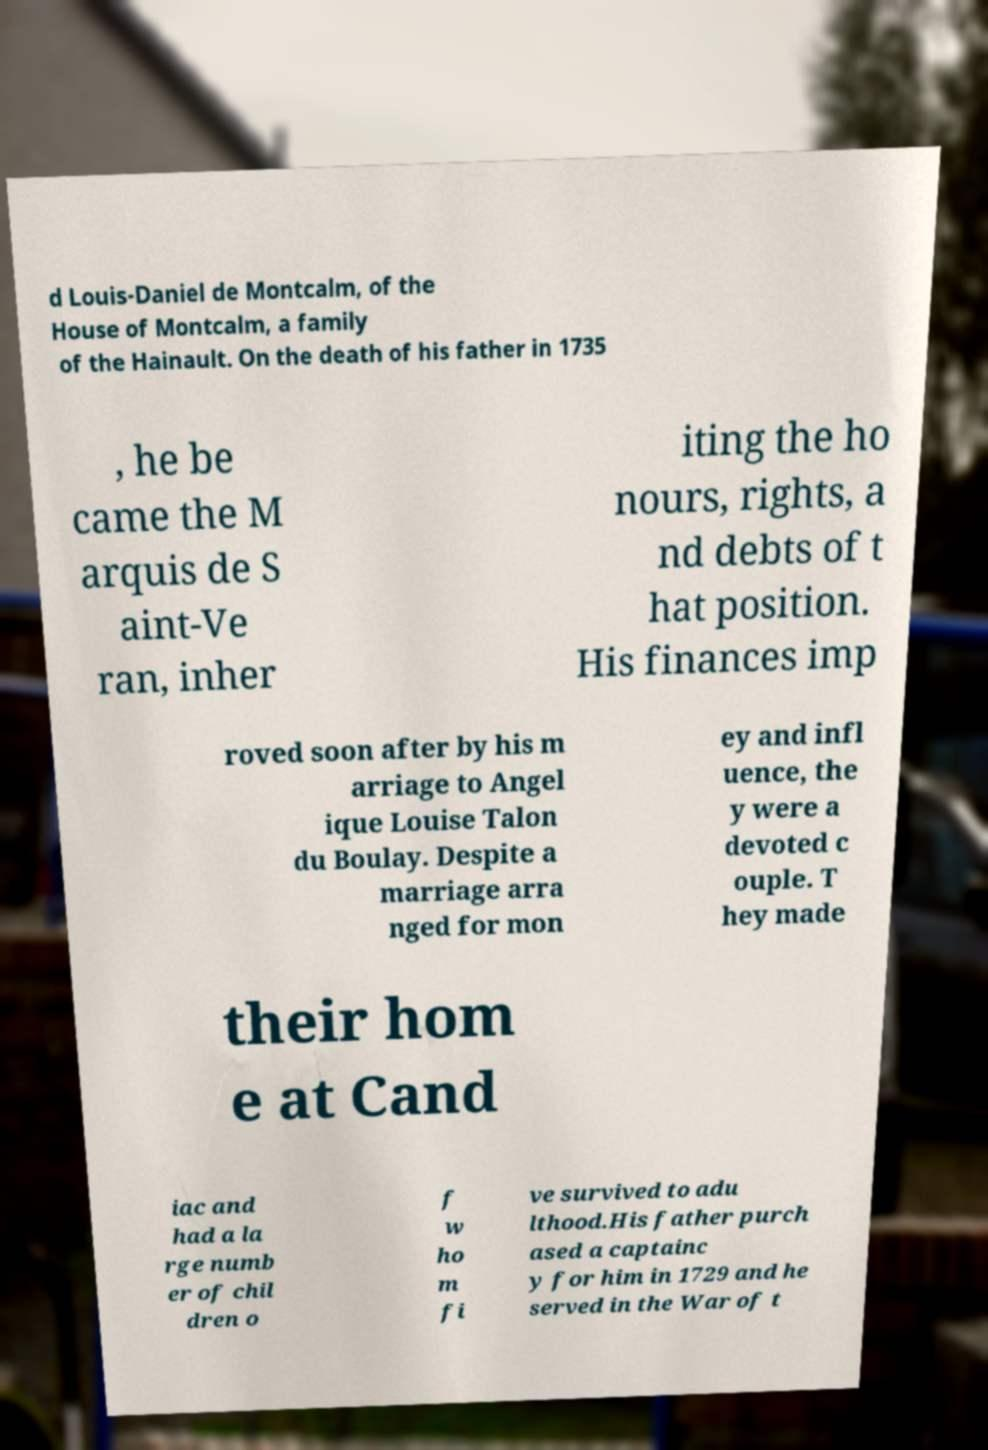Could you extract and type out the text from this image? d Louis-Daniel de Montcalm, of the House of Montcalm, a family of the Hainault. On the death of his father in 1735 , he be came the M arquis de S aint-Ve ran, inher iting the ho nours, rights, a nd debts of t hat position. His finances imp roved soon after by his m arriage to Angel ique Louise Talon du Boulay. Despite a marriage arra nged for mon ey and infl uence, the y were a devoted c ouple. T hey made their hom e at Cand iac and had a la rge numb er of chil dren o f w ho m fi ve survived to adu lthood.His father purch ased a captainc y for him in 1729 and he served in the War of t 